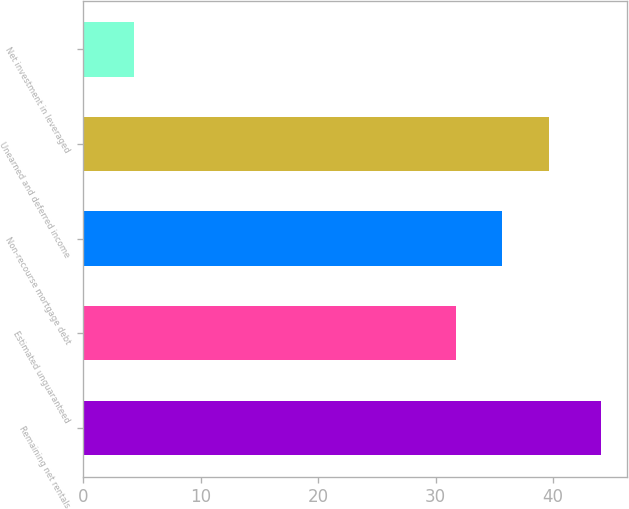Convert chart to OTSL. <chart><loc_0><loc_0><loc_500><loc_500><bar_chart><fcel>Remaining net rentals<fcel>Estimated unguaranteed<fcel>Non-recourse mortgage debt<fcel>Unearned and deferred income<fcel>Net investment in leveraged<nl><fcel>44.1<fcel>31.7<fcel>35.68<fcel>39.66<fcel>4.3<nl></chart> 